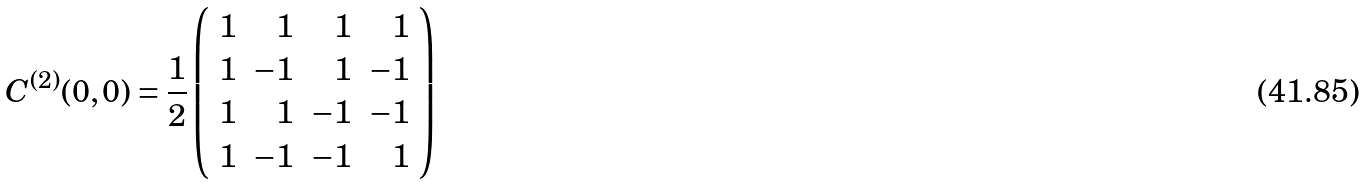<formula> <loc_0><loc_0><loc_500><loc_500>C ^ { ( 2 ) } ( 0 , 0 ) = \frac { 1 } { 2 } \left ( \begin{array} { r r r r } 1 & 1 & 1 & 1 \\ 1 & - 1 & 1 & - 1 \\ 1 & 1 & - 1 & - 1 \\ 1 & - 1 & - 1 & 1 \\ \end{array} \right )</formula> 